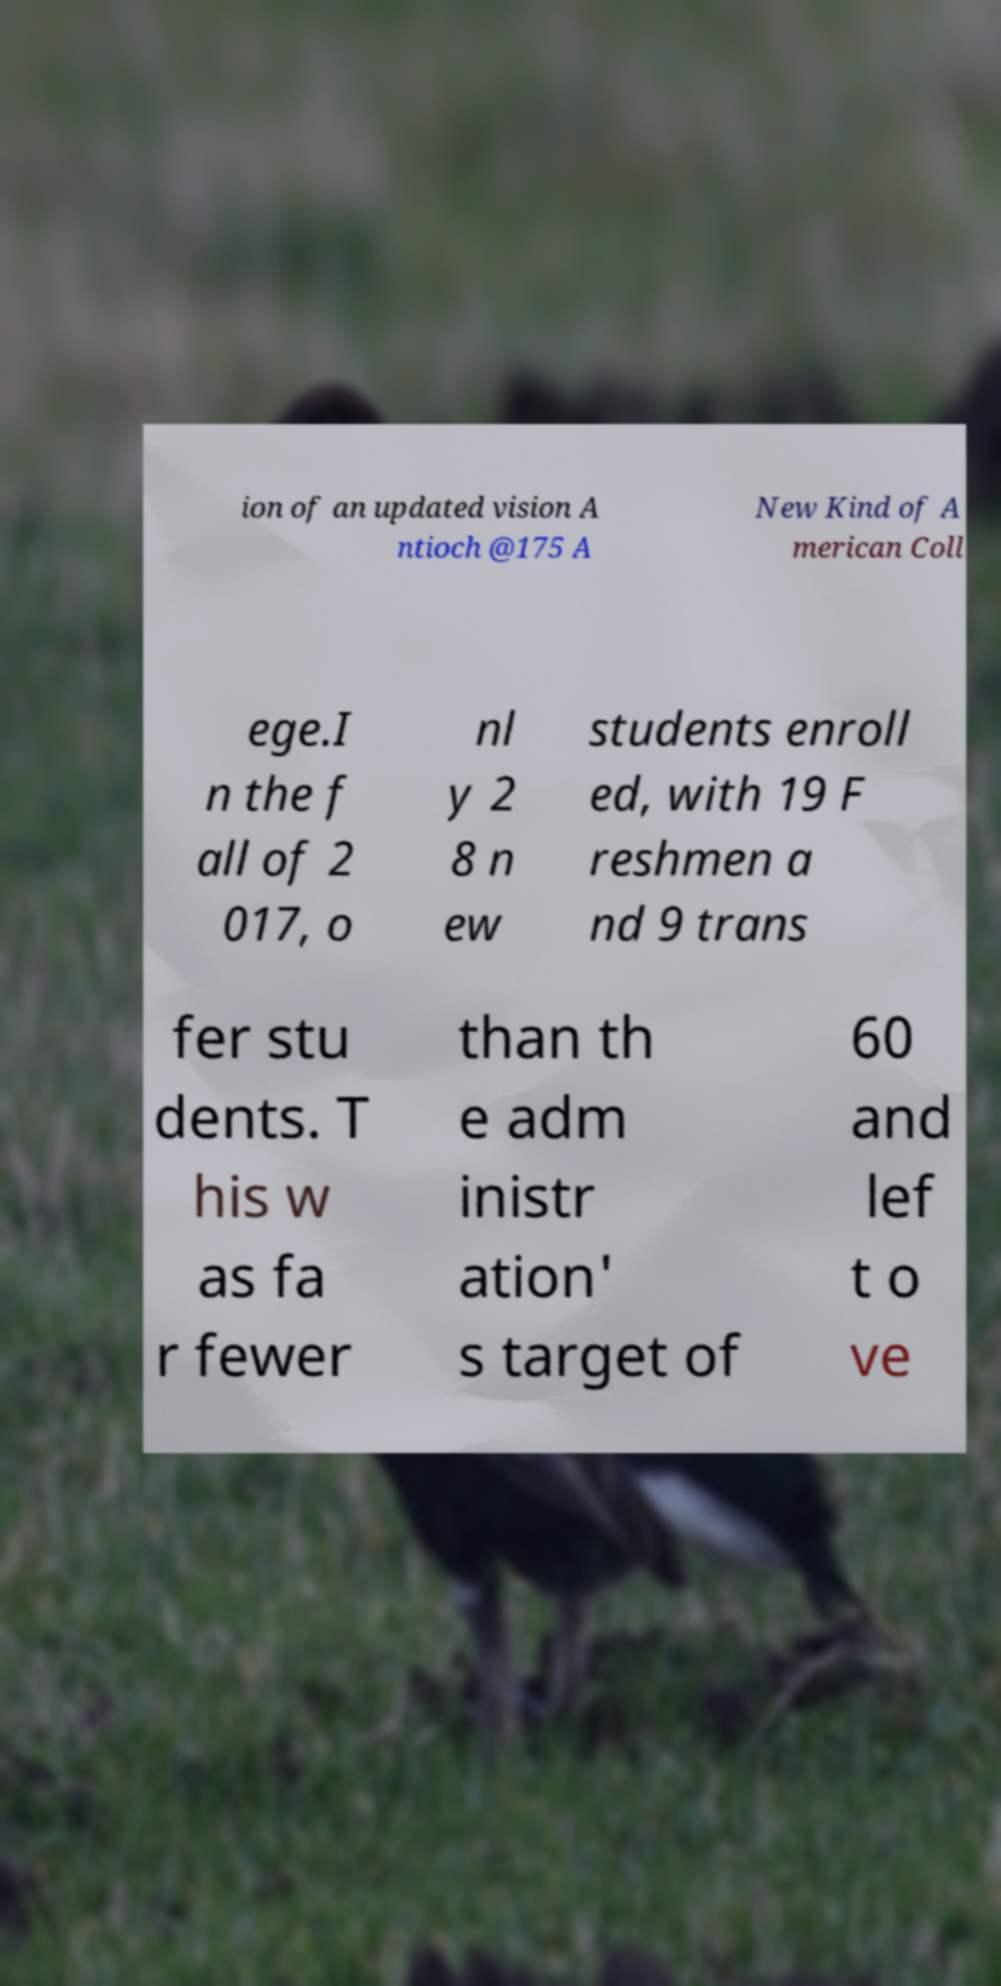For documentation purposes, I need the text within this image transcribed. Could you provide that? ion of an updated vision A ntioch @175 A New Kind of A merican Coll ege.I n the f all of 2 017, o nl y 2 8 n ew students enroll ed, with 19 F reshmen a nd 9 trans fer stu dents. T his w as fa r fewer than th e adm inistr ation' s target of 60 and lef t o ve 